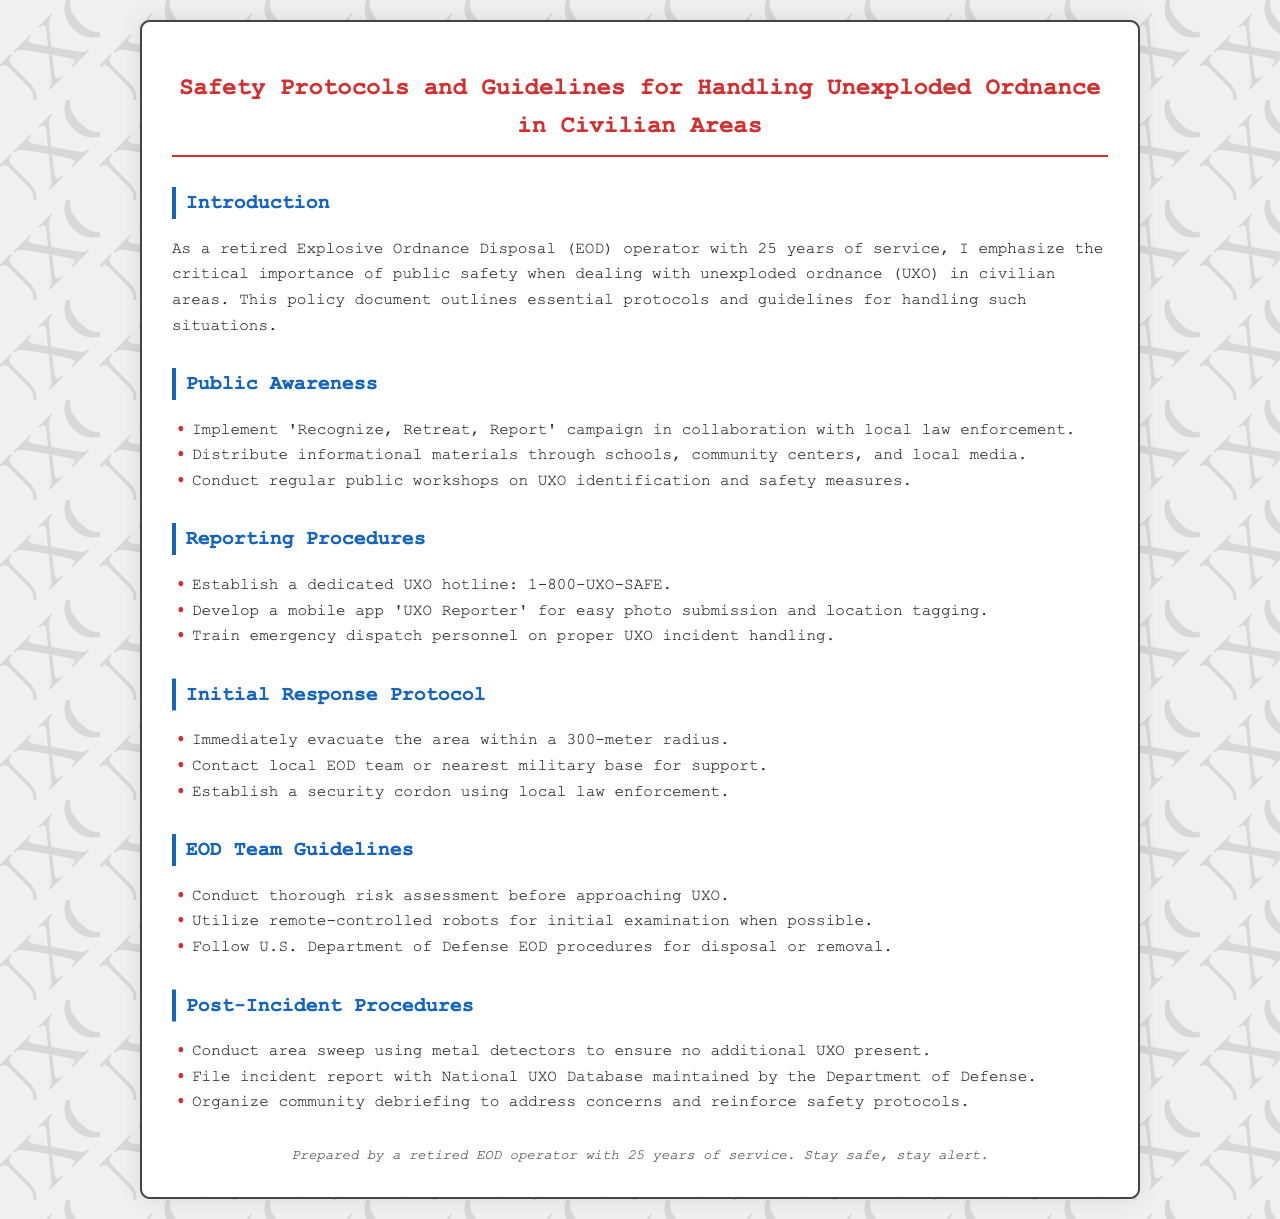What is the dedicated UXO hotline? The hotline is specifically established for reporting UXO incidents, which is 1-800-UXO-SAFE.
Answer: 1-800-UXO-SAFE What is the first step in the Initial Response Protocol? The Initial Response Protocol begins with evacuating the area within a 300-meter radius.
Answer: Evacuate the area within a 300-meter radius What campaign is suggested for public awareness? The document outlines the implementation of the 'Recognize, Retreat, Report' campaign.
Answer: Recognize, Retreat, Report What mobile app is mentioned in the Reporting Procedures? The document references the 'UXO Reporter' app for photo submission and location tagging.
Answer: UXO Reporter How far should the area be evacuated according to the Initial Response Protocol? The protocol specifies that the area should be evacuated within a radius of 300 meters.
Answer: 300 meters What should be done after a UXO incident according to the Post-Incident Procedures? The Post-Incident Procedures include conducting an area sweep using metal detectors.
Answer: Conduct area sweep using metal detectors Who is responsible for filing incident reports? Incident reports are to be filed with the National UXO Database maintained by the Department of Defense.
Answer: National UXO Database What should be established with local law enforcement during an incident? A security cordon should be established using local law enforcement.
Answer: Security cordon How often should public workshops on UXO be conducted? The document suggests conducting regular public workshops on UXO identification and safety measures.
Answer: Regularly 